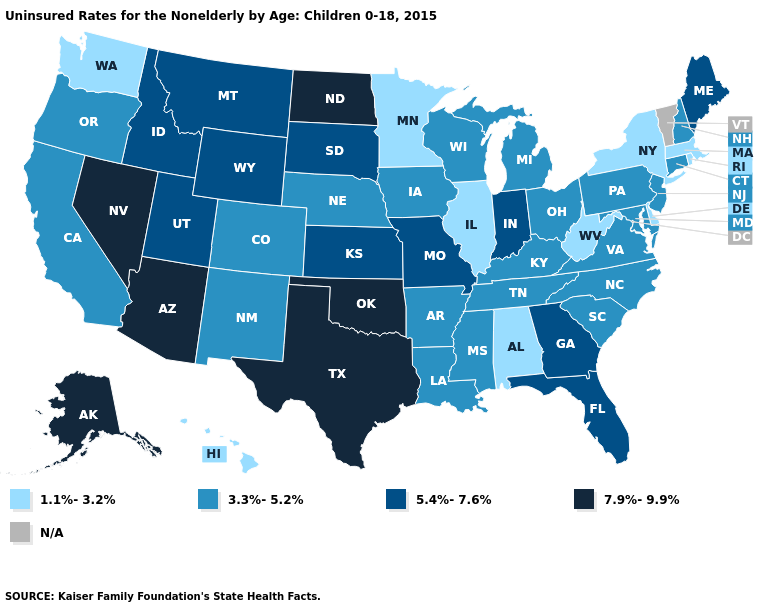Which states have the lowest value in the USA?
Give a very brief answer. Alabama, Delaware, Hawaii, Illinois, Massachusetts, Minnesota, New York, Rhode Island, Washington, West Virginia. Name the states that have a value in the range N/A?
Concise answer only. Vermont. What is the lowest value in the USA?
Write a very short answer. 1.1%-3.2%. Does Alaska have the highest value in the USA?
Short answer required. Yes. Name the states that have a value in the range 7.9%-9.9%?
Give a very brief answer. Alaska, Arizona, Nevada, North Dakota, Oklahoma, Texas. What is the value of Georgia?
Write a very short answer. 5.4%-7.6%. Name the states that have a value in the range N/A?
Answer briefly. Vermont. Name the states that have a value in the range 1.1%-3.2%?
Short answer required. Alabama, Delaware, Hawaii, Illinois, Massachusetts, Minnesota, New York, Rhode Island, Washington, West Virginia. Which states hav the highest value in the South?
Be succinct. Oklahoma, Texas. Does Washington have the lowest value in the USA?
Be succinct. Yes. Does the first symbol in the legend represent the smallest category?
Quick response, please. Yes. Which states have the lowest value in the USA?
Answer briefly. Alabama, Delaware, Hawaii, Illinois, Massachusetts, Minnesota, New York, Rhode Island, Washington, West Virginia. What is the highest value in the MidWest ?
Keep it brief. 7.9%-9.9%. How many symbols are there in the legend?
Write a very short answer. 5. 